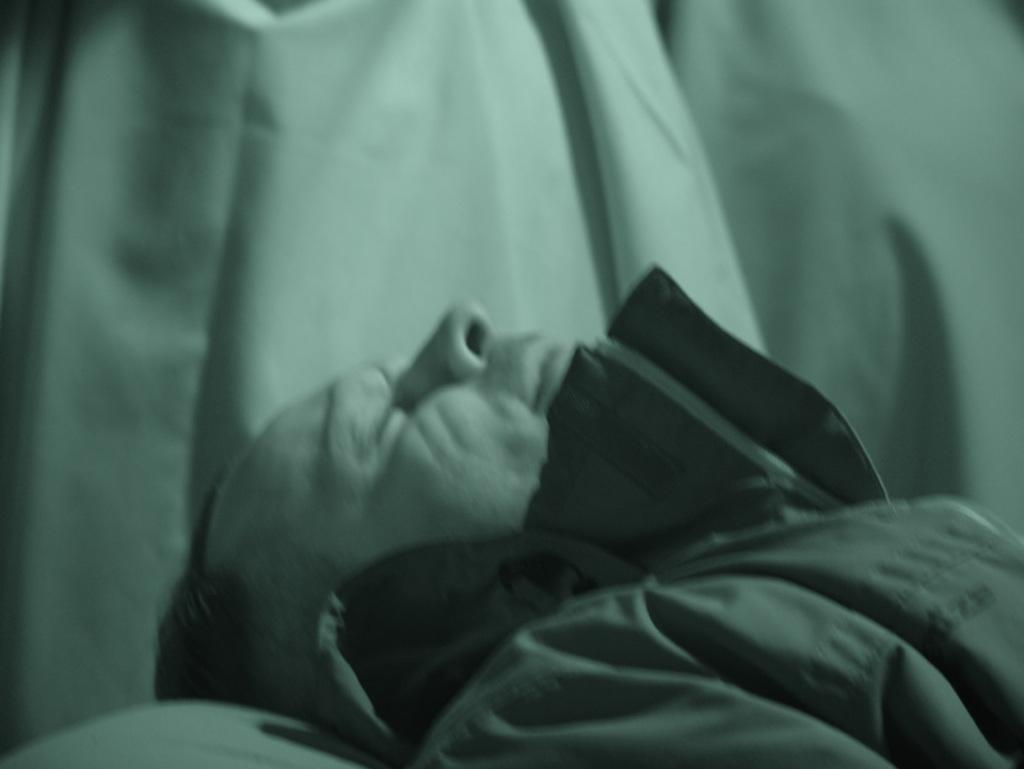What is the main subject of the image? The main subject of the image is a person's face. What is the person doing in the image? The person is sleeping. What type of competition is the person participating in while sleeping in the image? There is no competition present in the image; the person is simply sleeping. How many babies are visible in the image? There are no babies present in the image; it only features a person's face. 